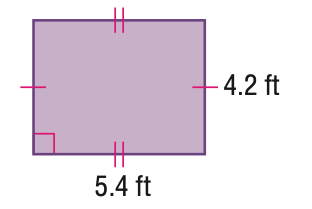Question: Find the perimeter of the parallelogram. Round to the nearest tenth if necessary.
Choices:
A. 16.8
B. 19.2
C. 21.6
D. 22.7
Answer with the letter. Answer: B Question: Find the area of the parallelogram. Round to the nearest tenth if necessary.
Choices:
A. 17.6
B. 19.2
C. 22.7
D. 29.2
Answer with the letter. Answer: C 